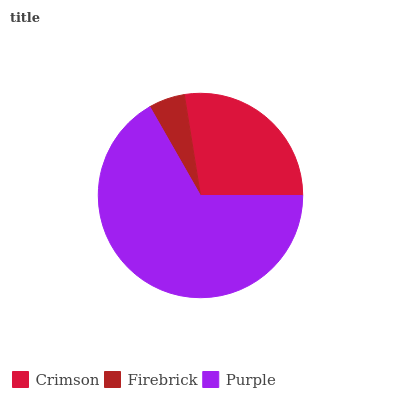Is Firebrick the minimum?
Answer yes or no. Yes. Is Purple the maximum?
Answer yes or no. Yes. Is Purple the minimum?
Answer yes or no. No. Is Firebrick the maximum?
Answer yes or no. No. Is Purple greater than Firebrick?
Answer yes or no. Yes. Is Firebrick less than Purple?
Answer yes or no. Yes. Is Firebrick greater than Purple?
Answer yes or no. No. Is Purple less than Firebrick?
Answer yes or no. No. Is Crimson the high median?
Answer yes or no. Yes. Is Crimson the low median?
Answer yes or no. Yes. Is Purple the high median?
Answer yes or no. No. Is Purple the low median?
Answer yes or no. No. 